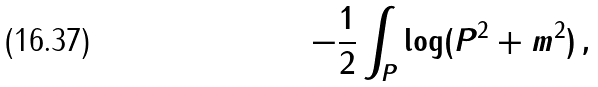<formula> <loc_0><loc_0><loc_500><loc_500>- \frac { 1 } { 2 } \int _ { P } \log ( P ^ { 2 } + m ^ { 2 } ) \, ,</formula> 